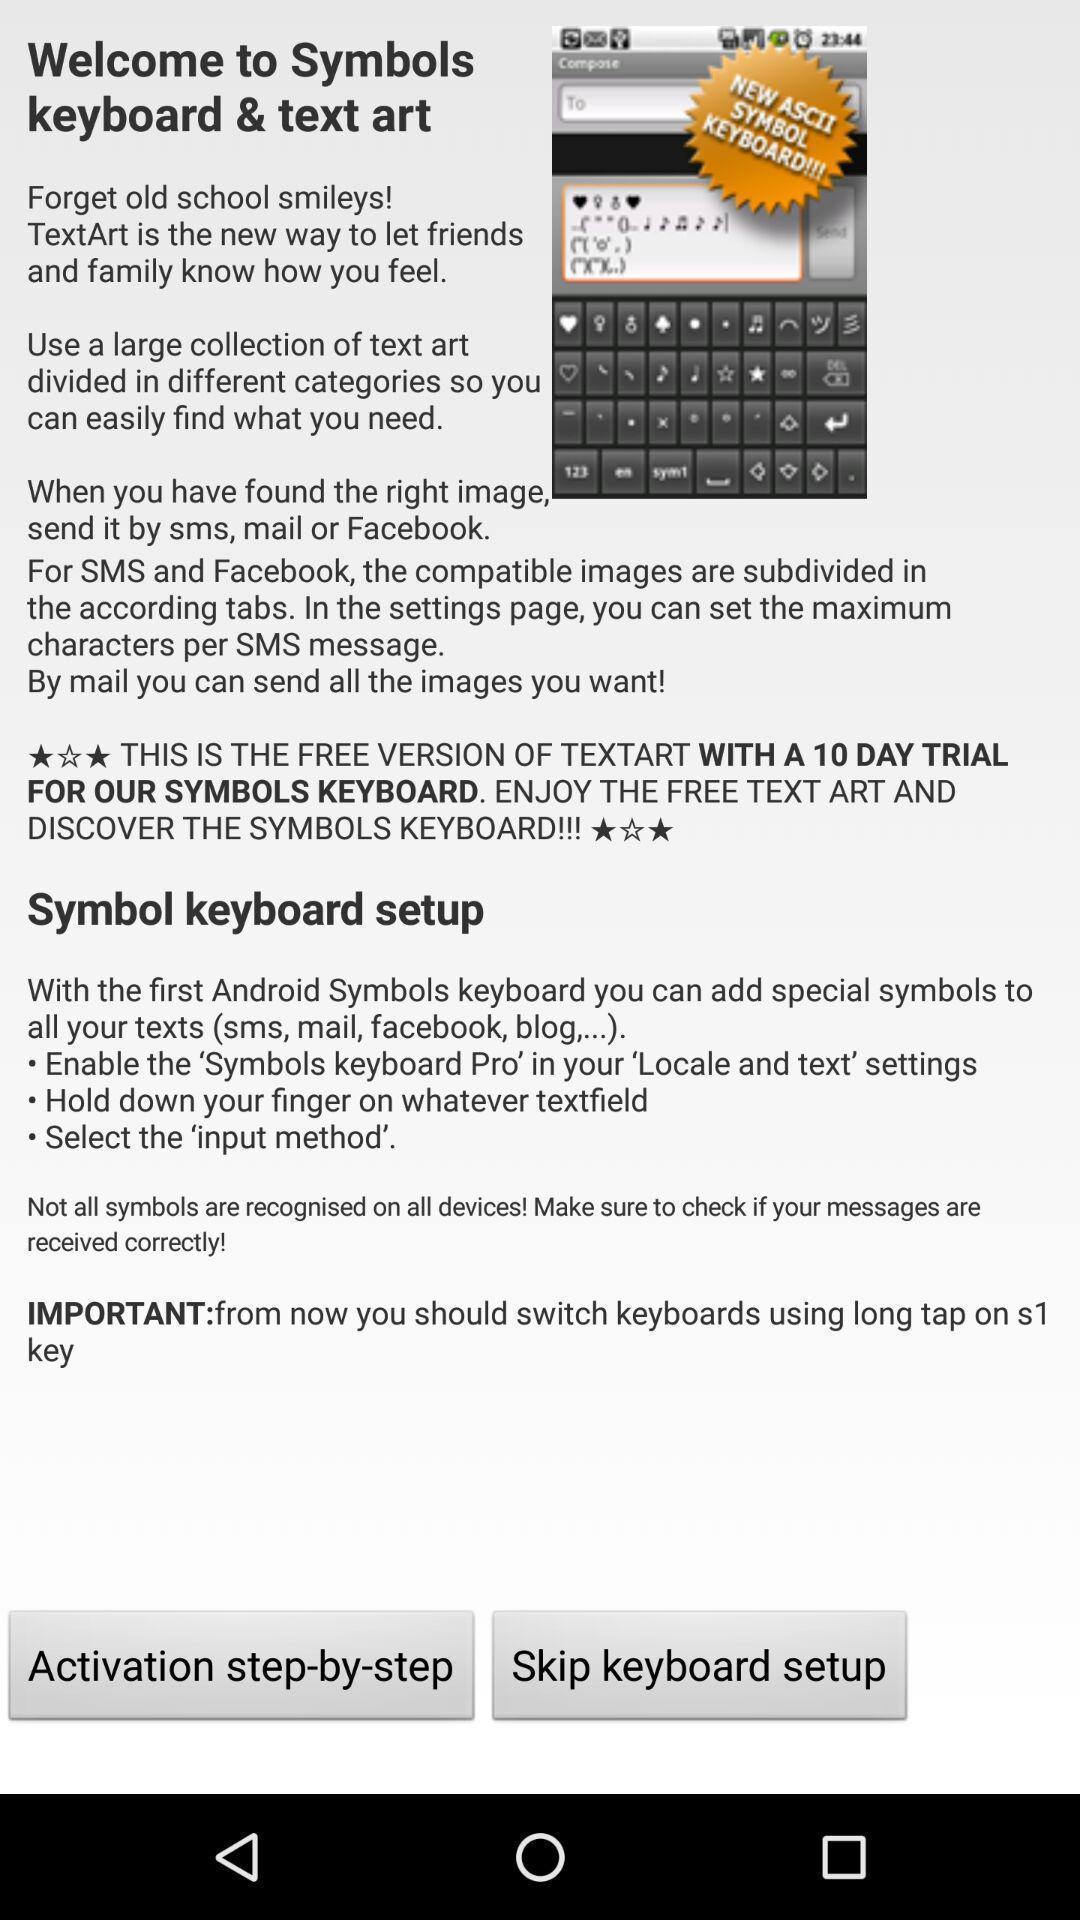What details can you identify in this image? Welcome page of social app. 